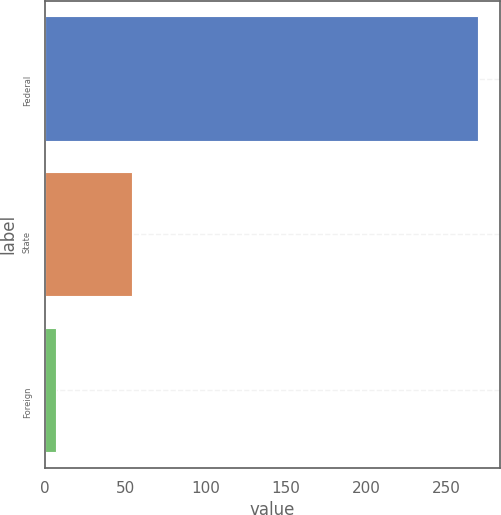Convert chart. <chart><loc_0><loc_0><loc_500><loc_500><bar_chart><fcel>Federal<fcel>State<fcel>Foreign<nl><fcel>269.7<fcel>54.3<fcel>6.8<nl></chart> 